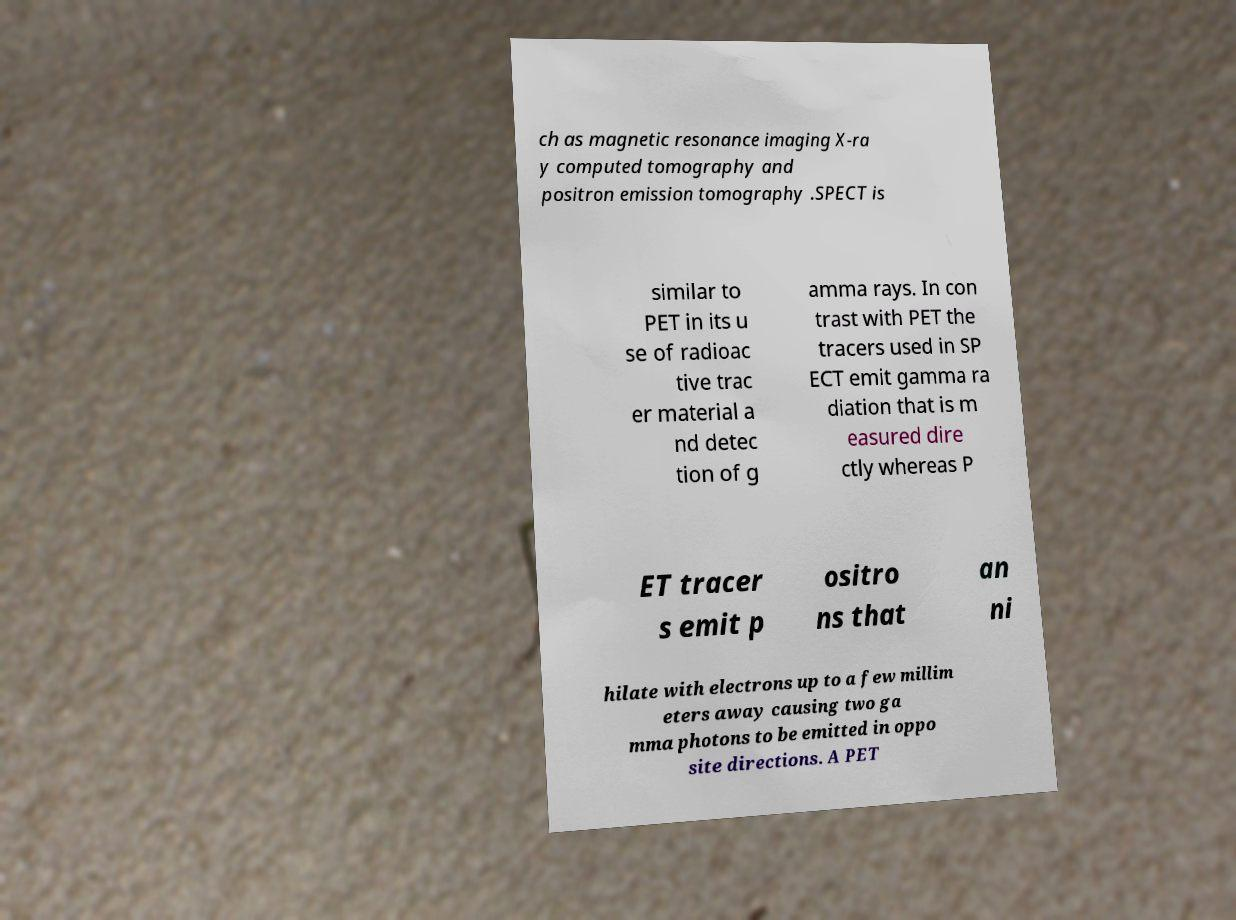Can you accurately transcribe the text from the provided image for me? ch as magnetic resonance imaging X-ra y computed tomography and positron emission tomography .SPECT is similar to PET in its u se of radioac tive trac er material a nd detec tion of g amma rays. In con trast with PET the tracers used in SP ECT emit gamma ra diation that is m easured dire ctly whereas P ET tracer s emit p ositro ns that an ni hilate with electrons up to a few millim eters away causing two ga mma photons to be emitted in oppo site directions. A PET 